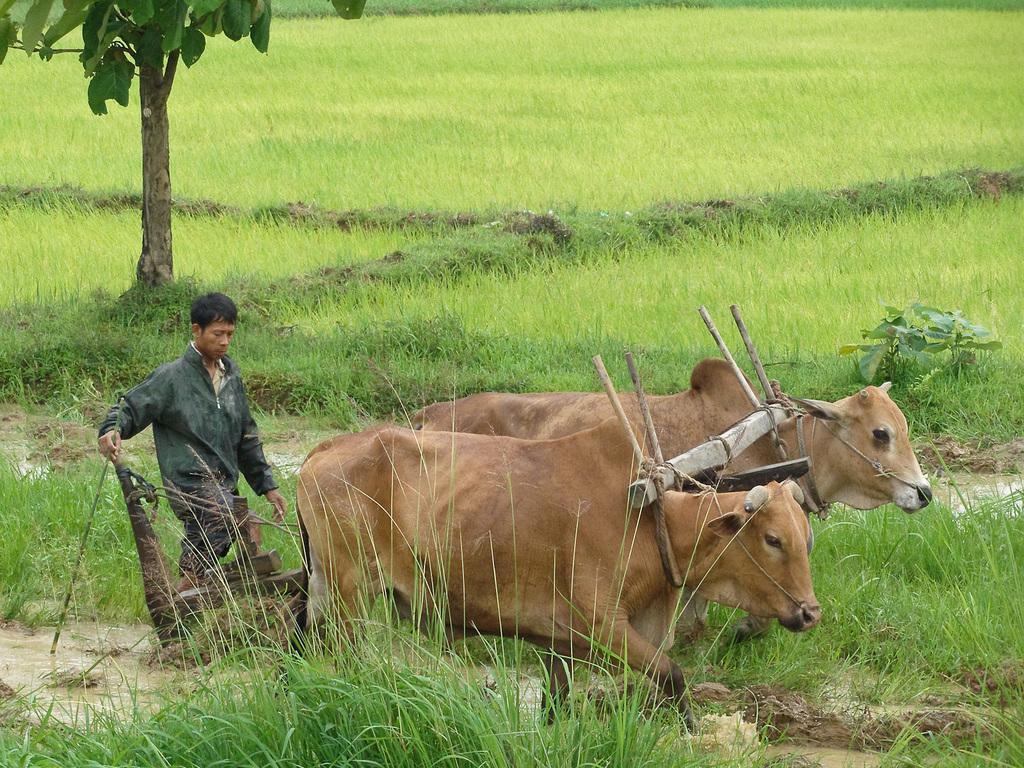How would you summarize this image in a sentence or two? In this picture there are cows in the center of the image and there is a man on the left side of the image, there is a tree at the top side of the image, there is grassland around the area of the image. 